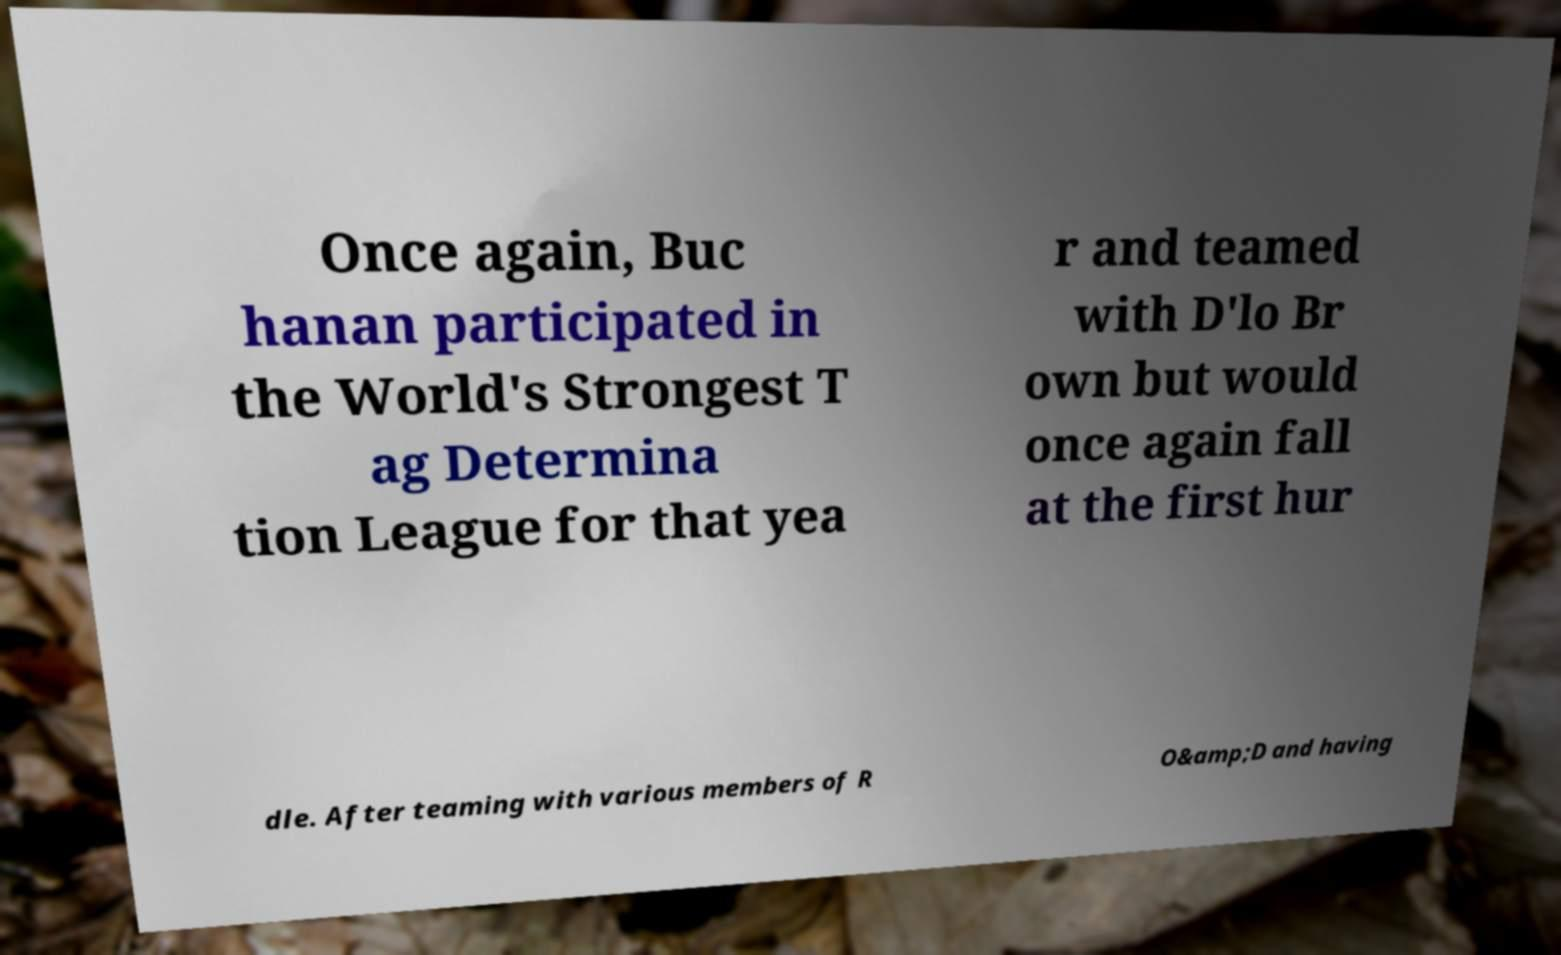There's text embedded in this image that I need extracted. Can you transcribe it verbatim? Once again, Buc hanan participated in the World's Strongest T ag Determina tion League for that yea r and teamed with D'lo Br own but would once again fall at the first hur dle. After teaming with various members of R O&amp;D and having 